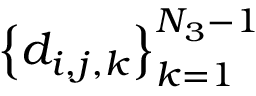Convert formula to latex. <formula><loc_0><loc_0><loc_500><loc_500>\left \{ d _ { i , j , k } \right \} _ { k = 1 } ^ { N _ { 3 } - 1 }</formula> 